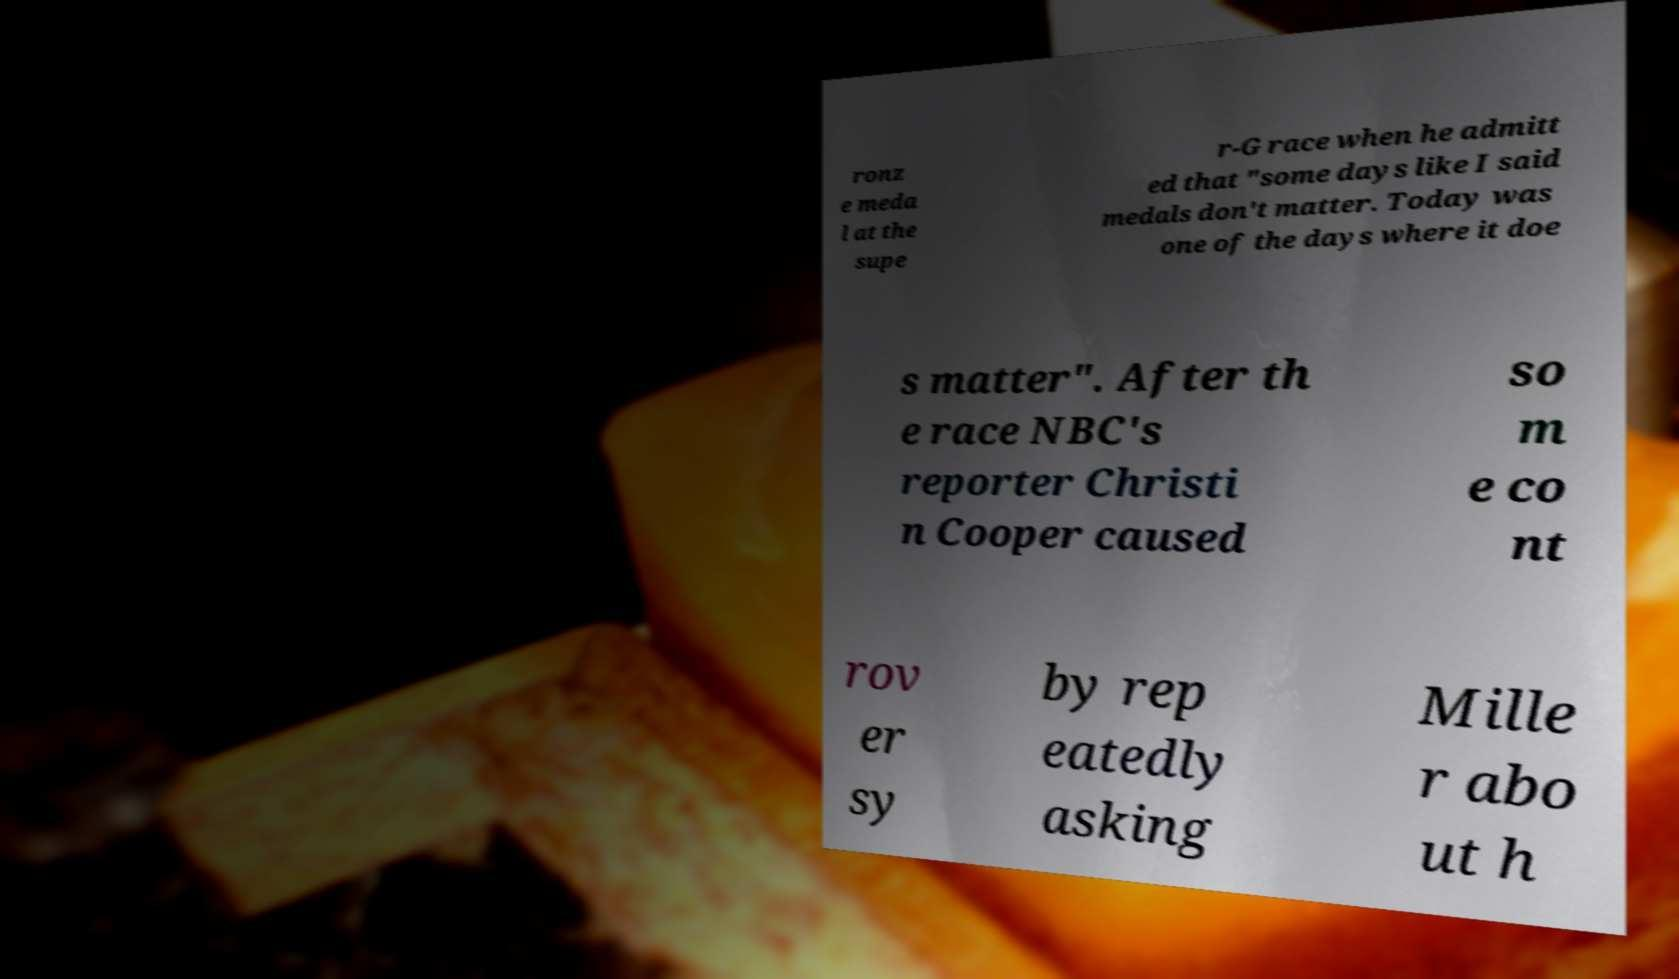There's text embedded in this image that I need extracted. Can you transcribe it verbatim? ronz e meda l at the supe r-G race when he admitt ed that "some days like I said medals don't matter. Today was one of the days where it doe s matter". After th e race NBC's reporter Christi n Cooper caused so m e co nt rov er sy by rep eatedly asking Mille r abo ut h 